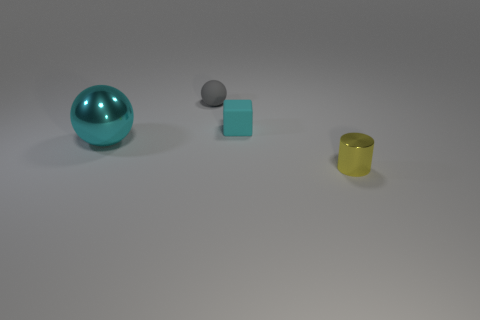Are the object that is to the left of the tiny gray matte sphere and the object that is in front of the big cyan shiny sphere made of the same material?
Keep it short and to the point. Yes. Are there any other things that are the same color as the large ball?
Provide a succinct answer. Yes. What color is the tiny thing that is the same shape as the large cyan metallic object?
Give a very brief answer. Gray. What is the size of the object that is on the left side of the tiny cyan matte thing and in front of the tiny rubber sphere?
Make the answer very short. Large. There is a metallic object behind the tiny metal cylinder; does it have the same shape as the object in front of the large metal sphere?
Your answer should be very brief. No. There is a metallic object that is the same color as the block; what shape is it?
Provide a short and direct response. Sphere. How many cyan spheres are made of the same material as the tiny yellow cylinder?
Provide a succinct answer. 1. What is the shape of the small object that is to the left of the tiny yellow metal thing and on the right side of the small gray matte ball?
Offer a terse response. Cube. Does the cyan object that is in front of the cyan matte block have the same material as the tiny yellow cylinder?
Ensure brevity in your answer.  Yes. Are there any other things that are made of the same material as the tiny sphere?
Your answer should be very brief. Yes. 